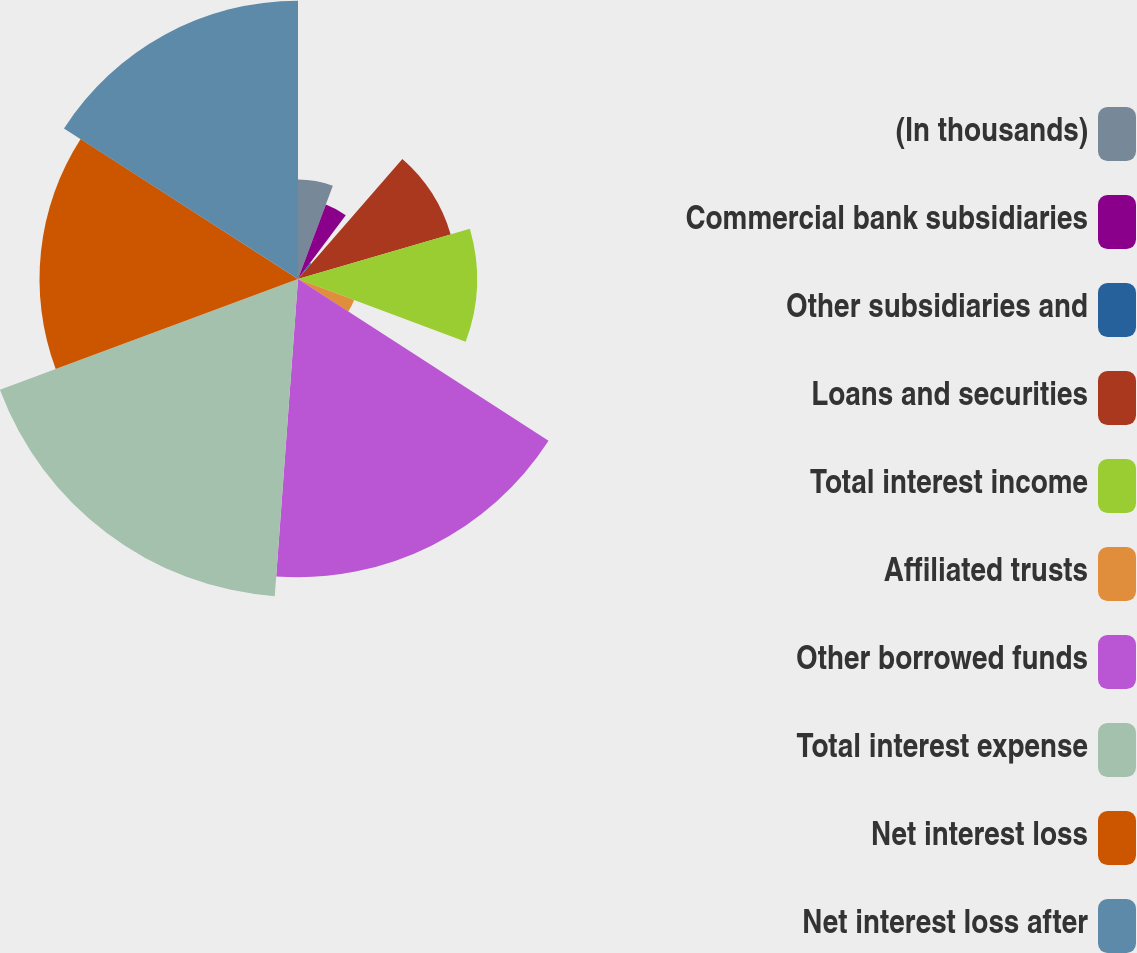Convert chart to OTSL. <chart><loc_0><loc_0><loc_500><loc_500><pie_chart><fcel>(In thousands)<fcel>Commercial bank subsidiaries<fcel>Other subsidiaries and<fcel>Loans and securities<fcel>Total interest income<fcel>Affiliated trusts<fcel>Other borrowed funds<fcel>Total interest expense<fcel>Net interest loss<fcel>Net interest loss after<nl><fcel>5.69%<fcel>4.55%<fcel>1.15%<fcel>9.09%<fcel>10.23%<fcel>3.42%<fcel>17.04%<fcel>18.17%<fcel>14.77%<fcel>15.9%<nl></chart> 